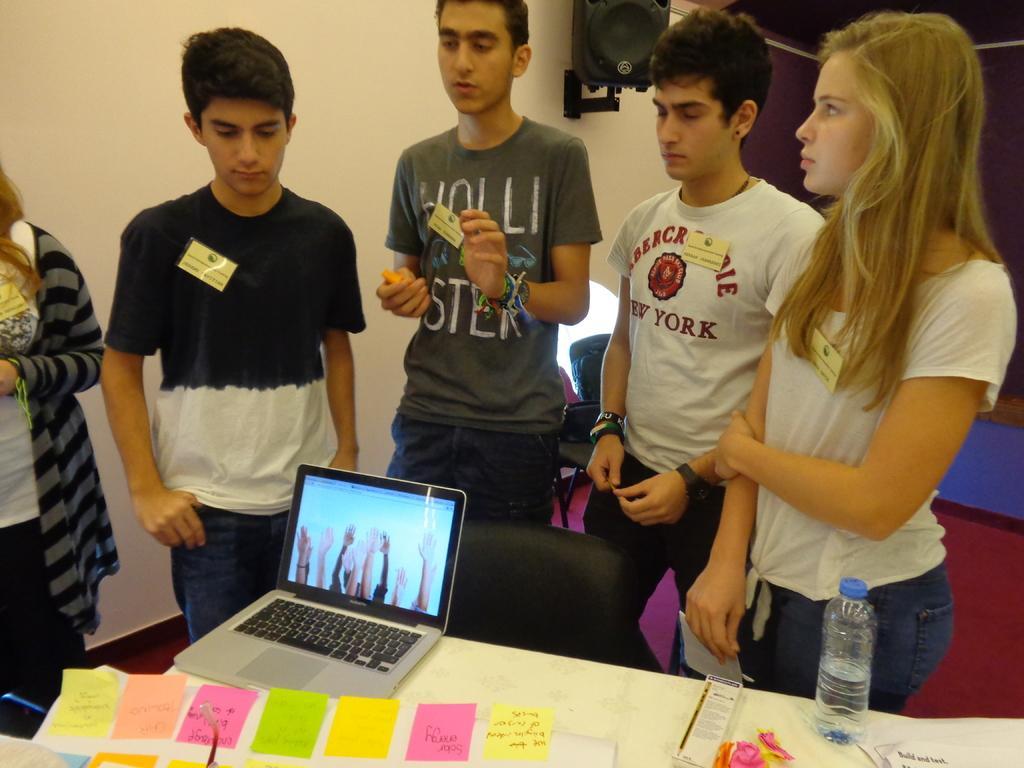In one or two sentences, can you explain what this image depicts? In the foreground of this picture, there are five persons standing near a table on which a laptop, bottle and few objects are placed on it. There is a chair in between persons and the table. In the background, there is a wall, chair and a speaker box on the wall. 